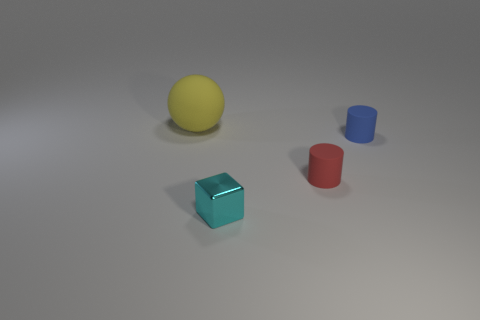Add 4 large yellow objects. How many objects exist? 8 Subtract all balls. How many objects are left? 3 Subtract 0 green cylinders. How many objects are left? 4 Subtract all red things. Subtract all small cylinders. How many objects are left? 1 Add 4 large yellow matte objects. How many large yellow matte objects are left? 5 Add 3 large yellow matte things. How many large yellow matte things exist? 4 